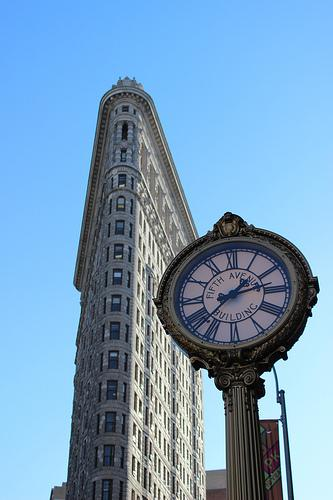Question: what is written on the clock's face?
Choices:
A. Rolex.
B. "Fifth Avenue Building".
C. Chanel.
D. Versace.
Answer with the letter. Answer: B Question: what are the two main objects in this photo?
Choices:
A. A building and a clock.
B. A man and a dog.
C. A bench and a cat.
D. A bird and a tree.
Answer with the letter. Answer: A Question: how many roman numerals are on the clock?
Choices:
A. 2.
B. 4.
C. 12.
D. 8.
Answer with the letter. Answer: C Question: what color is the sky?
Choices:
A. Red.
B. Blue.
C. Orange.
D. Purple.
Answer with the letter. Answer: B Question: what color is the clock?
Choices:
A. White.
B. Gold.
C. Silver.
D. Platinum.
Answer with the letter. Answer: B Question: what material is the building made out of?
Choices:
A. Concrete.
B. Wood.
C. Bricks.
D. Cedar shake.
Answer with the letter. Answer: C 